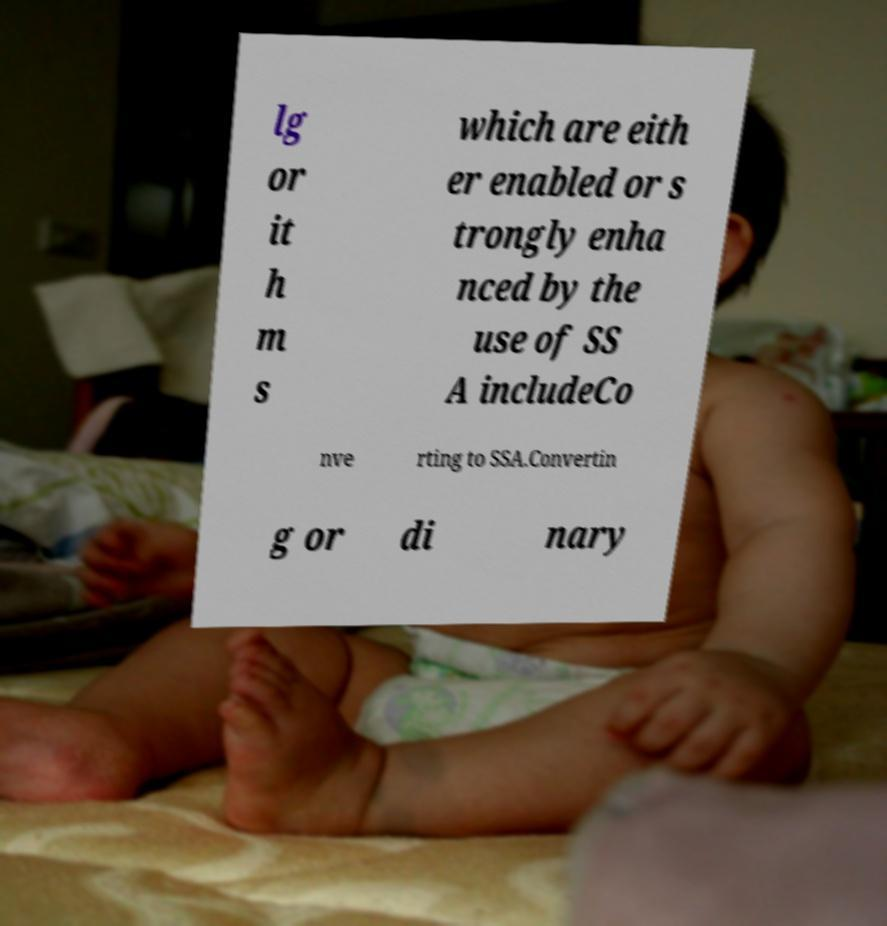Please identify and transcribe the text found in this image. lg or it h m s which are eith er enabled or s trongly enha nced by the use of SS A includeCo nve rting to SSA.Convertin g or di nary 